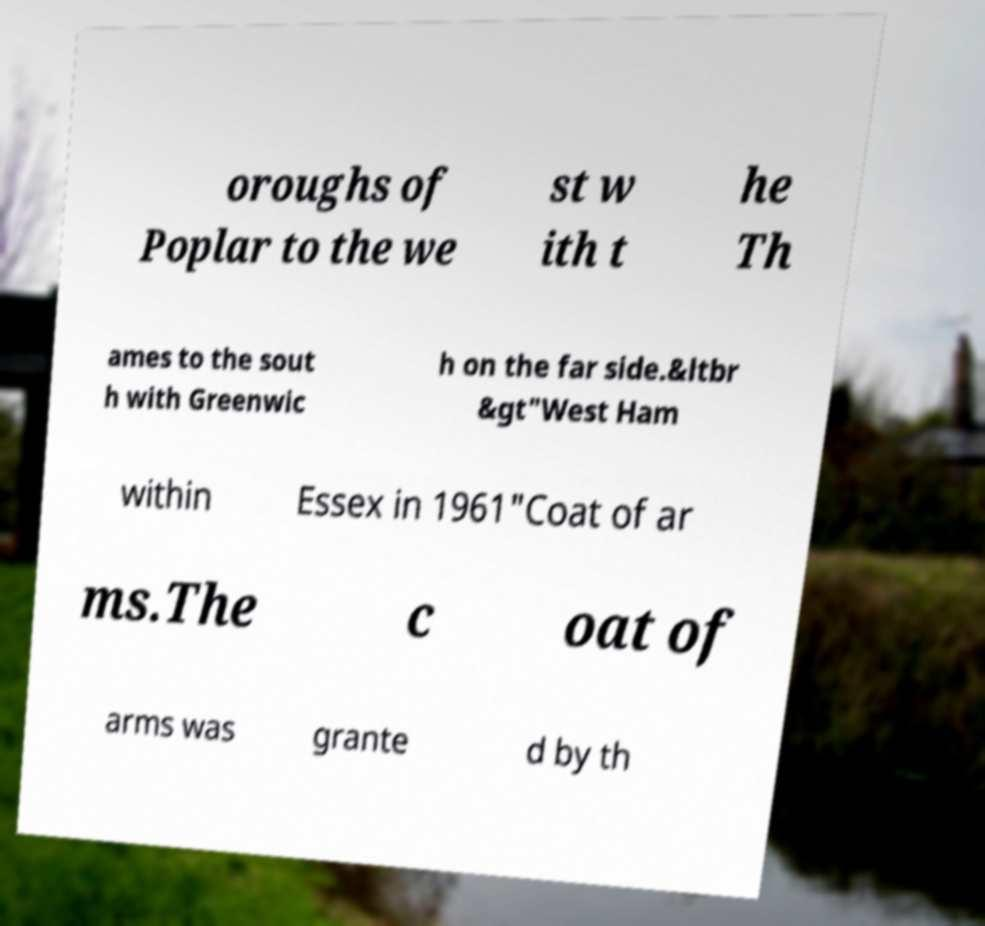Could you extract and type out the text from this image? oroughs of Poplar to the we st w ith t he Th ames to the sout h with Greenwic h on the far side.&ltbr &gt"West Ham within Essex in 1961"Coat of ar ms.The c oat of arms was grante d by th 